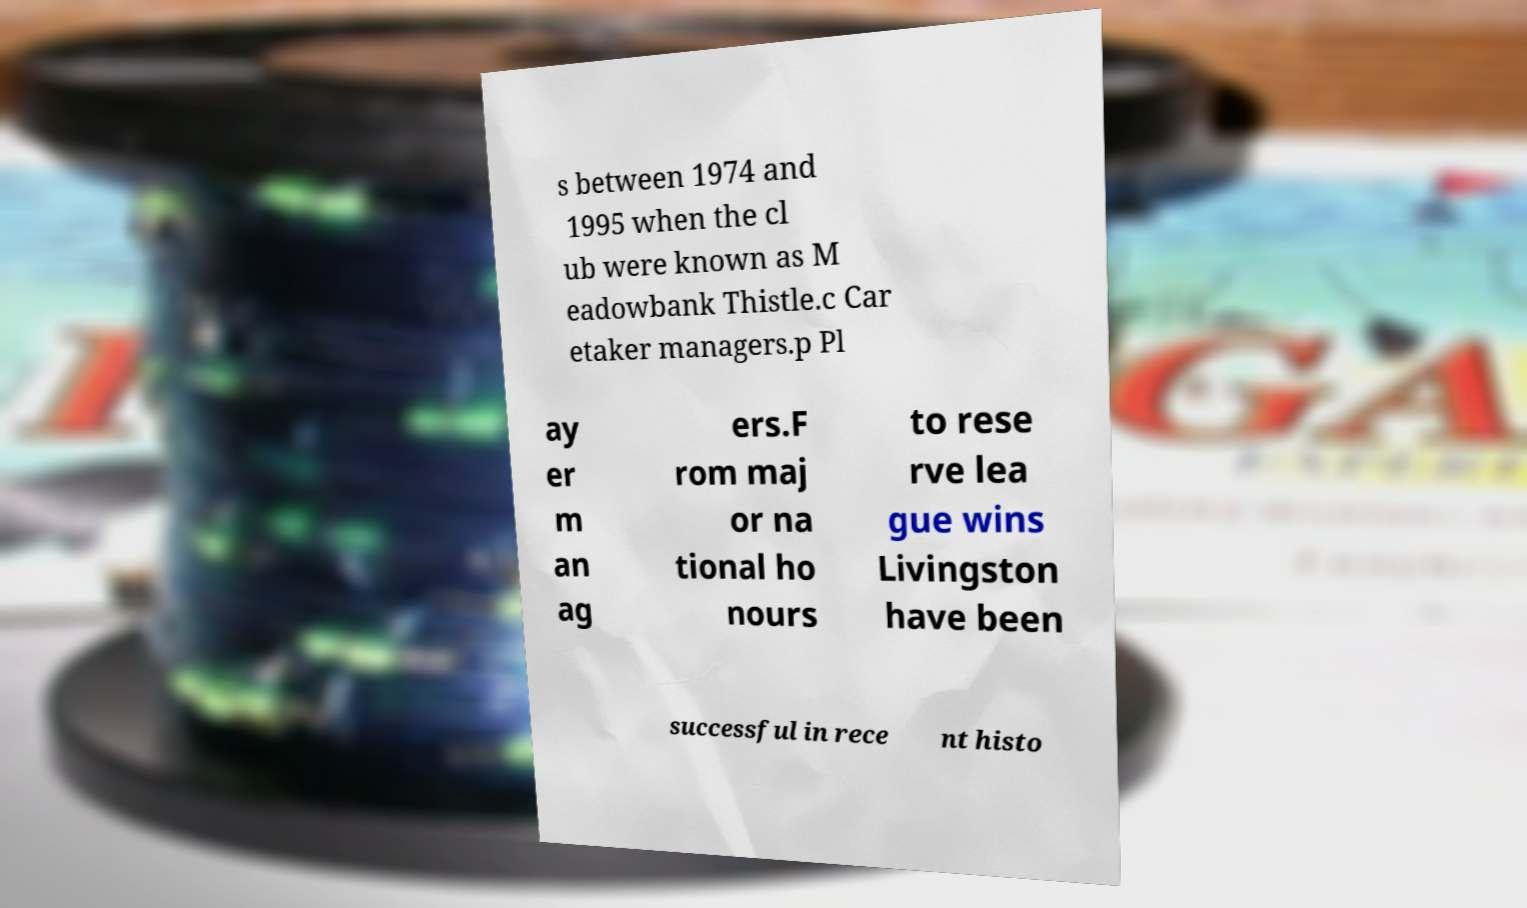Could you extract and type out the text from this image? s between 1974 and 1995 when the cl ub were known as M eadowbank Thistle.c Car etaker managers.p Pl ay er m an ag ers.F rom maj or na tional ho nours to rese rve lea gue wins Livingston have been successful in rece nt histo 